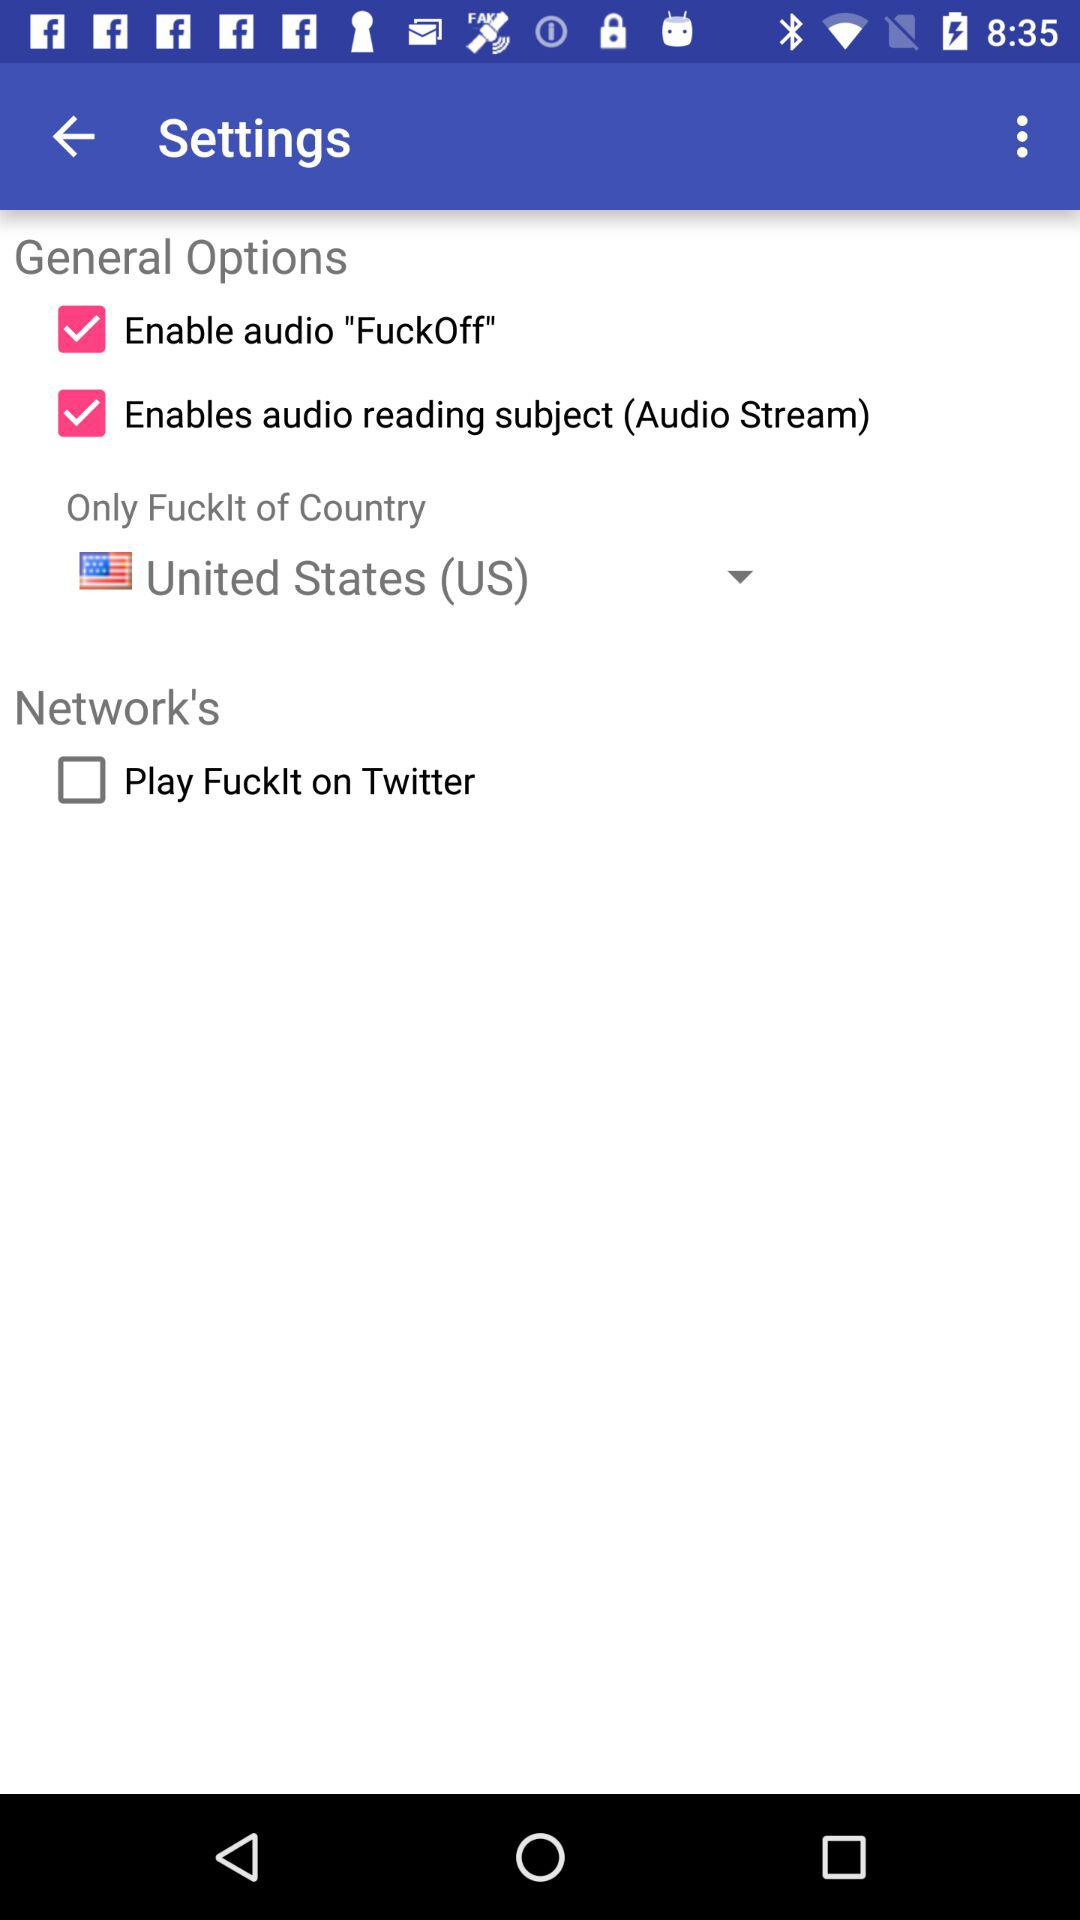How many options are there to enable audio?
Answer the question using a single word or phrase. 2 